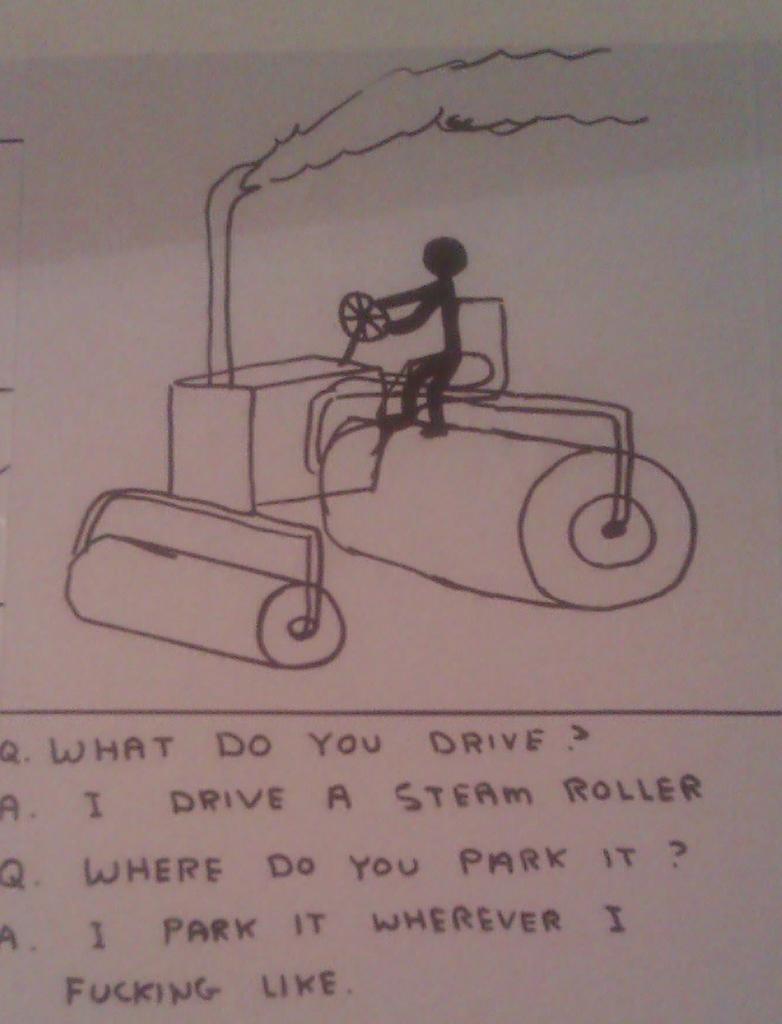Please provide a concise description of this image. In this image we can see a paper with the drawing and also the text. 